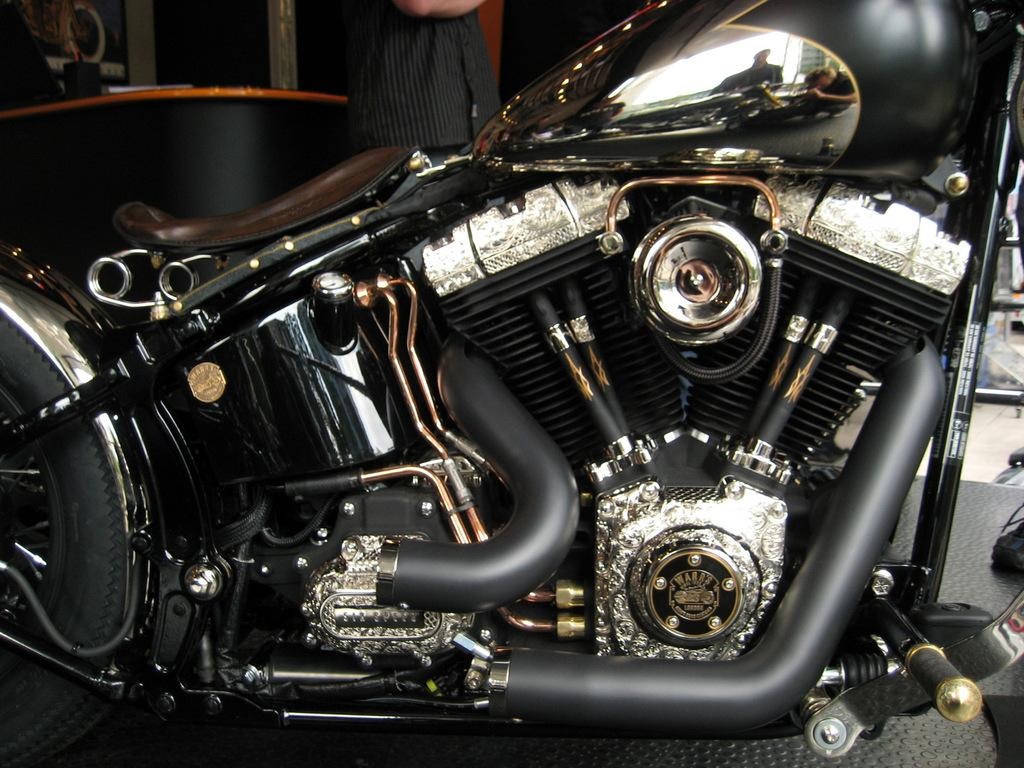What is the main object in the foreground of the image? There is a bike in the foreground of the image. Can you describe the background of the image? There is a man in the background of the image. What flavor of ice cream is the man eating in the image? There is no ice cream present in the image, and the man is not eating anything. 